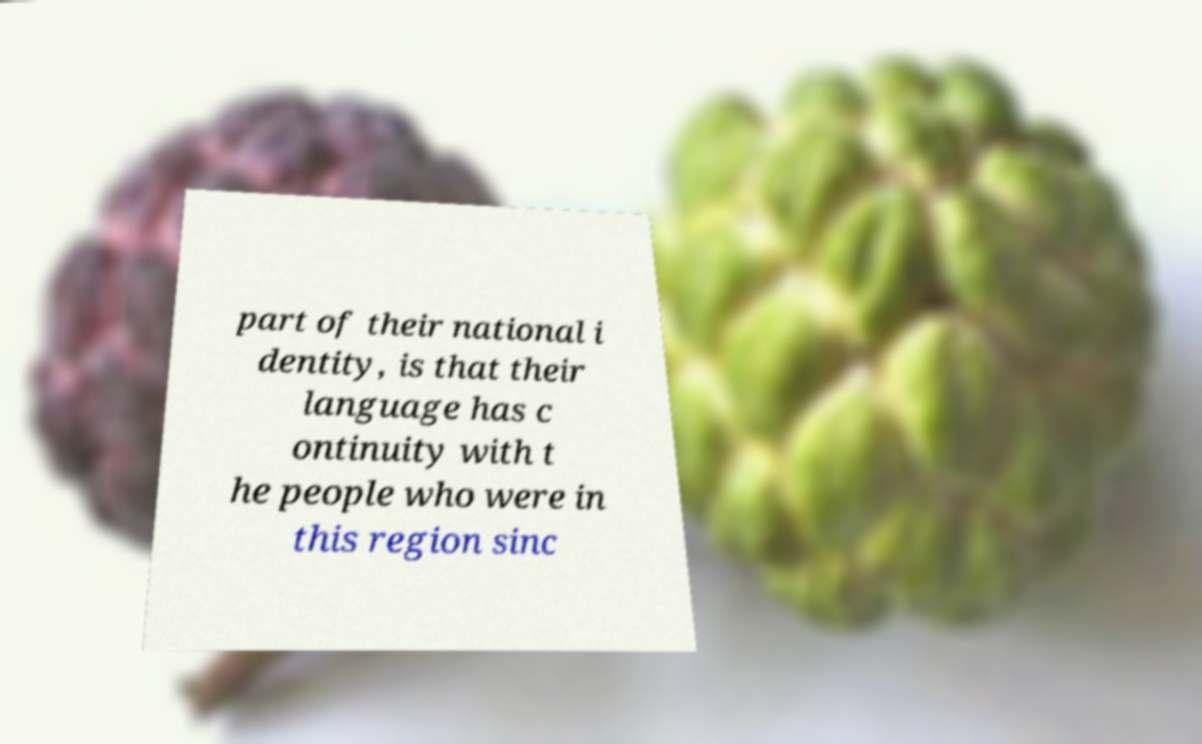Can you read and provide the text displayed in the image?This photo seems to have some interesting text. Can you extract and type it out for me? part of their national i dentity, is that their language has c ontinuity with t he people who were in this region sinc 